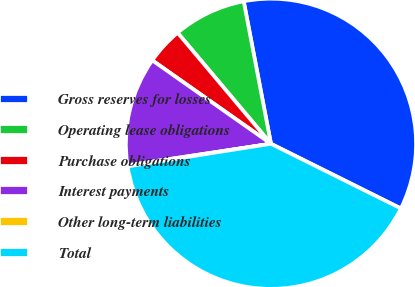Convert chart. <chart><loc_0><loc_0><loc_500><loc_500><pie_chart><fcel>Gross reserves for losses<fcel>Operating lease obligations<fcel>Purchase obligations<fcel>Interest payments<fcel>Other long-term liabilities<fcel>Total<nl><fcel>35.36%<fcel>8.12%<fcel>4.12%<fcel>12.13%<fcel>0.11%<fcel>40.16%<nl></chart> 